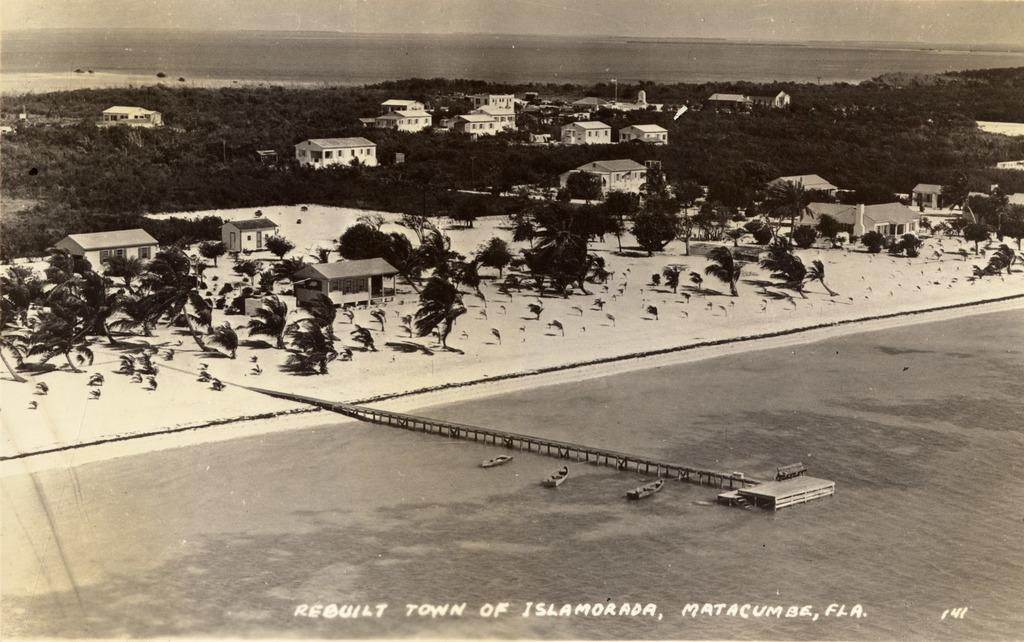<image>
Summarize the visual content of the image. An aerial image of Islamorada, Florida is shown in black and white. 